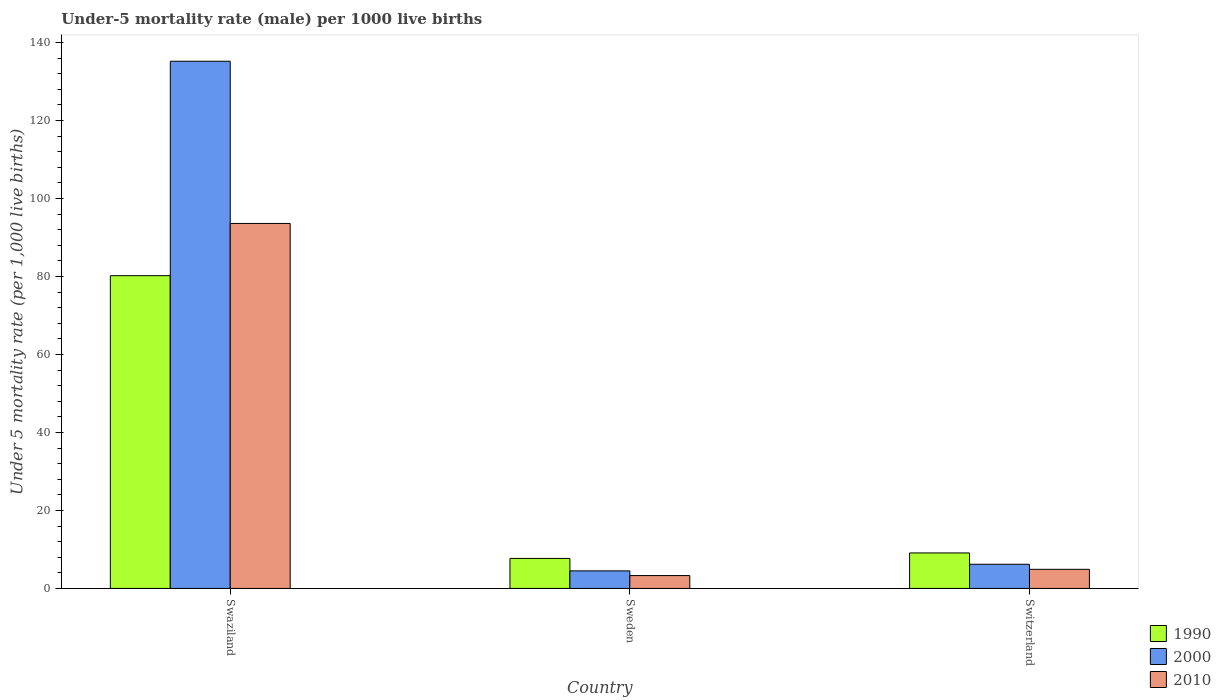Are the number of bars per tick equal to the number of legend labels?
Offer a terse response. Yes. Are the number of bars on each tick of the X-axis equal?
Your answer should be compact. Yes. How many bars are there on the 1st tick from the left?
Offer a terse response. 3. How many bars are there on the 1st tick from the right?
Keep it short and to the point. 3. What is the label of the 1st group of bars from the left?
Ensure brevity in your answer.  Swaziland. In how many cases, is the number of bars for a given country not equal to the number of legend labels?
Give a very brief answer. 0. What is the under-five mortality rate in 2000 in Sweden?
Your answer should be compact. 4.5. Across all countries, what is the maximum under-five mortality rate in 2010?
Give a very brief answer. 93.6. Across all countries, what is the minimum under-five mortality rate in 1990?
Your answer should be very brief. 7.7. In which country was the under-five mortality rate in 1990 maximum?
Ensure brevity in your answer.  Swaziland. In which country was the under-five mortality rate in 1990 minimum?
Give a very brief answer. Sweden. What is the total under-five mortality rate in 2010 in the graph?
Give a very brief answer. 101.8. What is the difference between the under-five mortality rate in 2000 in Sweden and that in Switzerland?
Provide a short and direct response. -1.7. What is the difference between the under-five mortality rate in 1990 in Switzerland and the under-five mortality rate in 2000 in Swaziland?
Ensure brevity in your answer.  -126.1. What is the average under-five mortality rate in 1990 per country?
Offer a very short reply. 32.33. What is the difference between the under-five mortality rate of/in 2000 and under-five mortality rate of/in 1990 in Sweden?
Provide a succinct answer. -3.2. In how many countries, is the under-five mortality rate in 1990 greater than 24?
Ensure brevity in your answer.  1. What is the ratio of the under-five mortality rate in 1990 in Swaziland to that in Sweden?
Offer a terse response. 10.42. Is the under-five mortality rate in 2010 in Swaziland less than that in Switzerland?
Give a very brief answer. No. What is the difference between the highest and the second highest under-five mortality rate in 2010?
Offer a very short reply. -1.6. What is the difference between the highest and the lowest under-five mortality rate in 2000?
Offer a very short reply. 130.7. In how many countries, is the under-five mortality rate in 2000 greater than the average under-five mortality rate in 2000 taken over all countries?
Provide a succinct answer. 1. Is the sum of the under-five mortality rate in 2010 in Swaziland and Switzerland greater than the maximum under-five mortality rate in 2000 across all countries?
Make the answer very short. No. What does the 1st bar from the right in Sweden represents?
Your answer should be compact. 2010. Is it the case that in every country, the sum of the under-five mortality rate in 2010 and under-five mortality rate in 2000 is greater than the under-five mortality rate in 1990?
Give a very brief answer. Yes. How many bars are there?
Your answer should be compact. 9. Are all the bars in the graph horizontal?
Make the answer very short. No. How many countries are there in the graph?
Provide a short and direct response. 3. What is the difference between two consecutive major ticks on the Y-axis?
Provide a short and direct response. 20. Does the graph contain grids?
Your response must be concise. No. Where does the legend appear in the graph?
Give a very brief answer. Bottom right. How many legend labels are there?
Keep it short and to the point. 3. What is the title of the graph?
Your answer should be compact. Under-5 mortality rate (male) per 1000 live births. What is the label or title of the Y-axis?
Provide a succinct answer. Under 5 mortality rate (per 1,0 live births). What is the Under 5 mortality rate (per 1,000 live births) of 1990 in Swaziland?
Provide a short and direct response. 80.2. What is the Under 5 mortality rate (per 1,000 live births) in 2000 in Swaziland?
Your answer should be compact. 135.2. What is the Under 5 mortality rate (per 1,000 live births) in 2010 in Swaziland?
Your answer should be very brief. 93.6. What is the Under 5 mortality rate (per 1,000 live births) of 2000 in Sweden?
Your answer should be compact. 4.5. What is the Under 5 mortality rate (per 1,000 live births) in 2010 in Sweden?
Give a very brief answer. 3.3. What is the Under 5 mortality rate (per 1,000 live births) in 2000 in Switzerland?
Your answer should be compact. 6.2. Across all countries, what is the maximum Under 5 mortality rate (per 1,000 live births) of 1990?
Keep it short and to the point. 80.2. Across all countries, what is the maximum Under 5 mortality rate (per 1,000 live births) in 2000?
Your answer should be very brief. 135.2. Across all countries, what is the maximum Under 5 mortality rate (per 1,000 live births) in 2010?
Offer a terse response. 93.6. Across all countries, what is the minimum Under 5 mortality rate (per 1,000 live births) of 1990?
Give a very brief answer. 7.7. Across all countries, what is the minimum Under 5 mortality rate (per 1,000 live births) of 2000?
Provide a short and direct response. 4.5. What is the total Under 5 mortality rate (per 1,000 live births) of 1990 in the graph?
Your answer should be compact. 97. What is the total Under 5 mortality rate (per 1,000 live births) of 2000 in the graph?
Offer a very short reply. 145.9. What is the total Under 5 mortality rate (per 1,000 live births) in 2010 in the graph?
Your response must be concise. 101.8. What is the difference between the Under 5 mortality rate (per 1,000 live births) in 1990 in Swaziland and that in Sweden?
Give a very brief answer. 72.5. What is the difference between the Under 5 mortality rate (per 1,000 live births) in 2000 in Swaziland and that in Sweden?
Your response must be concise. 130.7. What is the difference between the Under 5 mortality rate (per 1,000 live births) in 2010 in Swaziland and that in Sweden?
Make the answer very short. 90.3. What is the difference between the Under 5 mortality rate (per 1,000 live births) of 1990 in Swaziland and that in Switzerland?
Ensure brevity in your answer.  71.1. What is the difference between the Under 5 mortality rate (per 1,000 live births) of 2000 in Swaziland and that in Switzerland?
Your answer should be compact. 129. What is the difference between the Under 5 mortality rate (per 1,000 live births) in 2010 in Swaziland and that in Switzerland?
Offer a very short reply. 88.7. What is the difference between the Under 5 mortality rate (per 1,000 live births) of 1990 in Sweden and that in Switzerland?
Give a very brief answer. -1.4. What is the difference between the Under 5 mortality rate (per 1,000 live births) in 2010 in Sweden and that in Switzerland?
Make the answer very short. -1.6. What is the difference between the Under 5 mortality rate (per 1,000 live births) in 1990 in Swaziland and the Under 5 mortality rate (per 1,000 live births) in 2000 in Sweden?
Provide a succinct answer. 75.7. What is the difference between the Under 5 mortality rate (per 1,000 live births) of 1990 in Swaziland and the Under 5 mortality rate (per 1,000 live births) of 2010 in Sweden?
Provide a succinct answer. 76.9. What is the difference between the Under 5 mortality rate (per 1,000 live births) in 2000 in Swaziland and the Under 5 mortality rate (per 1,000 live births) in 2010 in Sweden?
Your answer should be very brief. 131.9. What is the difference between the Under 5 mortality rate (per 1,000 live births) of 1990 in Swaziland and the Under 5 mortality rate (per 1,000 live births) of 2010 in Switzerland?
Your response must be concise. 75.3. What is the difference between the Under 5 mortality rate (per 1,000 live births) of 2000 in Swaziland and the Under 5 mortality rate (per 1,000 live births) of 2010 in Switzerland?
Provide a succinct answer. 130.3. What is the difference between the Under 5 mortality rate (per 1,000 live births) in 1990 in Sweden and the Under 5 mortality rate (per 1,000 live births) in 2010 in Switzerland?
Provide a succinct answer. 2.8. What is the difference between the Under 5 mortality rate (per 1,000 live births) in 2000 in Sweden and the Under 5 mortality rate (per 1,000 live births) in 2010 in Switzerland?
Your response must be concise. -0.4. What is the average Under 5 mortality rate (per 1,000 live births) of 1990 per country?
Provide a short and direct response. 32.33. What is the average Under 5 mortality rate (per 1,000 live births) of 2000 per country?
Provide a succinct answer. 48.63. What is the average Under 5 mortality rate (per 1,000 live births) in 2010 per country?
Provide a short and direct response. 33.93. What is the difference between the Under 5 mortality rate (per 1,000 live births) in 1990 and Under 5 mortality rate (per 1,000 live births) in 2000 in Swaziland?
Your response must be concise. -55. What is the difference between the Under 5 mortality rate (per 1,000 live births) of 1990 and Under 5 mortality rate (per 1,000 live births) of 2010 in Swaziland?
Keep it short and to the point. -13.4. What is the difference between the Under 5 mortality rate (per 1,000 live births) of 2000 and Under 5 mortality rate (per 1,000 live births) of 2010 in Swaziland?
Offer a very short reply. 41.6. What is the difference between the Under 5 mortality rate (per 1,000 live births) in 1990 and Under 5 mortality rate (per 1,000 live births) in 2000 in Sweden?
Offer a very short reply. 3.2. What is the difference between the Under 5 mortality rate (per 1,000 live births) in 1990 and Under 5 mortality rate (per 1,000 live births) in 2010 in Sweden?
Provide a succinct answer. 4.4. What is the difference between the Under 5 mortality rate (per 1,000 live births) of 2000 and Under 5 mortality rate (per 1,000 live births) of 2010 in Sweden?
Your response must be concise. 1.2. What is the difference between the Under 5 mortality rate (per 1,000 live births) of 1990 and Under 5 mortality rate (per 1,000 live births) of 2010 in Switzerland?
Provide a short and direct response. 4.2. What is the ratio of the Under 5 mortality rate (per 1,000 live births) in 1990 in Swaziland to that in Sweden?
Your response must be concise. 10.42. What is the ratio of the Under 5 mortality rate (per 1,000 live births) of 2000 in Swaziland to that in Sweden?
Give a very brief answer. 30.04. What is the ratio of the Under 5 mortality rate (per 1,000 live births) in 2010 in Swaziland to that in Sweden?
Your answer should be compact. 28.36. What is the ratio of the Under 5 mortality rate (per 1,000 live births) in 1990 in Swaziland to that in Switzerland?
Provide a short and direct response. 8.81. What is the ratio of the Under 5 mortality rate (per 1,000 live births) in 2000 in Swaziland to that in Switzerland?
Provide a short and direct response. 21.81. What is the ratio of the Under 5 mortality rate (per 1,000 live births) of 2010 in Swaziland to that in Switzerland?
Offer a very short reply. 19.1. What is the ratio of the Under 5 mortality rate (per 1,000 live births) in 1990 in Sweden to that in Switzerland?
Offer a very short reply. 0.85. What is the ratio of the Under 5 mortality rate (per 1,000 live births) of 2000 in Sweden to that in Switzerland?
Provide a succinct answer. 0.73. What is the ratio of the Under 5 mortality rate (per 1,000 live births) of 2010 in Sweden to that in Switzerland?
Your answer should be compact. 0.67. What is the difference between the highest and the second highest Under 5 mortality rate (per 1,000 live births) of 1990?
Your answer should be very brief. 71.1. What is the difference between the highest and the second highest Under 5 mortality rate (per 1,000 live births) in 2000?
Give a very brief answer. 129. What is the difference between the highest and the second highest Under 5 mortality rate (per 1,000 live births) of 2010?
Provide a succinct answer. 88.7. What is the difference between the highest and the lowest Under 5 mortality rate (per 1,000 live births) in 1990?
Provide a succinct answer. 72.5. What is the difference between the highest and the lowest Under 5 mortality rate (per 1,000 live births) of 2000?
Offer a terse response. 130.7. What is the difference between the highest and the lowest Under 5 mortality rate (per 1,000 live births) in 2010?
Your response must be concise. 90.3. 